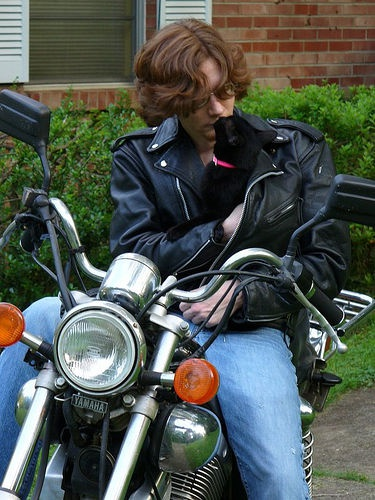Describe the objects in this image and their specific colors. I can see motorcycle in darkgray, black, white, and gray tones, people in darkgray, black, gray, and darkblue tones, and cat in darkgray, black, gray, and maroon tones in this image. 